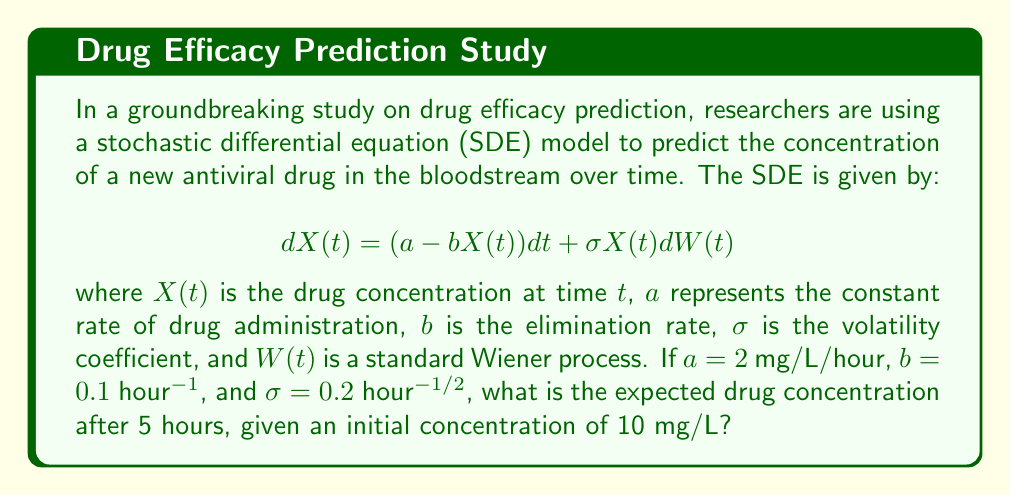Solve this math problem. To solve this problem, we need to use the properties of the Itô SDE and its solution. For the given SDE:

$$dX(t) = (a - bX(t))dt + \sigma X(t)dW(t)$$

The expected value of $X(t)$ satisfies the ordinary differential equation:

$$\frac{d}{dt}E[X(t)] = a - bE[X(t)]$$

This is because the expected value of the Itô integral term is zero.

The solution to this ODE is:

$$E[X(t)] = \frac{a}{b} + (X(0) - \frac{a}{b})e^{-bt}$$

where $X(0)$ is the initial concentration.

Given:
$a = 2$ mg/L/hour
$b = 0.1$ hour^(-1)
$\sigma = 0.2$ hour^(-1/2)
$X(0) = 10$ mg/L
$t = 5$ hours

Let's substitute these values into the equation:

$$E[X(5)] = \frac{2}{0.1} + (10 - \frac{2}{0.1})e^{-0.1 \cdot 5}$$

$$E[X(5)] = 20 + (10 - 20)e^{-0.5}$$

$$E[X(5)] = 20 - 10e^{-0.5}$$

$$E[X(5)] = 20 - 10 \cdot 0.6065$$

$$E[X(5)] = 20 - 6.065$$

$$E[X(5)] = 13.935$$

Therefore, the expected drug concentration after 5 hours is approximately 13.935 mg/L.
Answer: 13.935 mg/L 